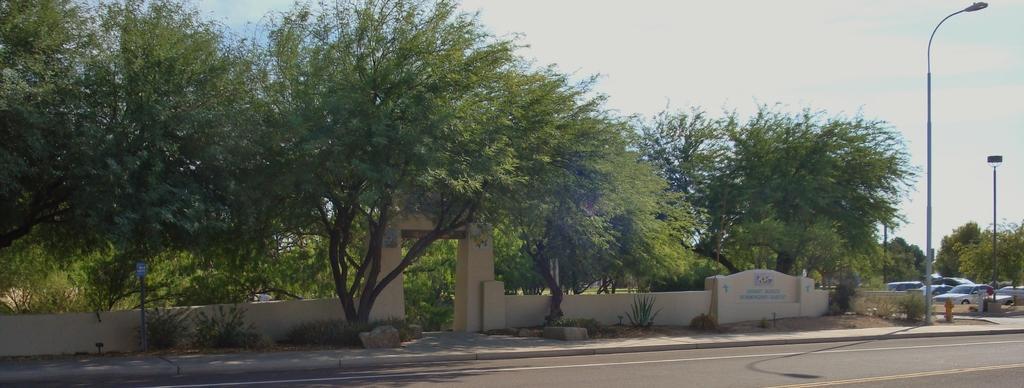Can you describe this image briefly? This image is taken outdoors. At the top of the image there is the sky with clouds. At the bottom of the image there is a road. In the middle of the image there are many trees and plants with leaves, stems and branches. There is a wall and there is a text on the wall. There is a signboard. On the right side of the image there are two poles with street lights and many cars are parked on the ground. 